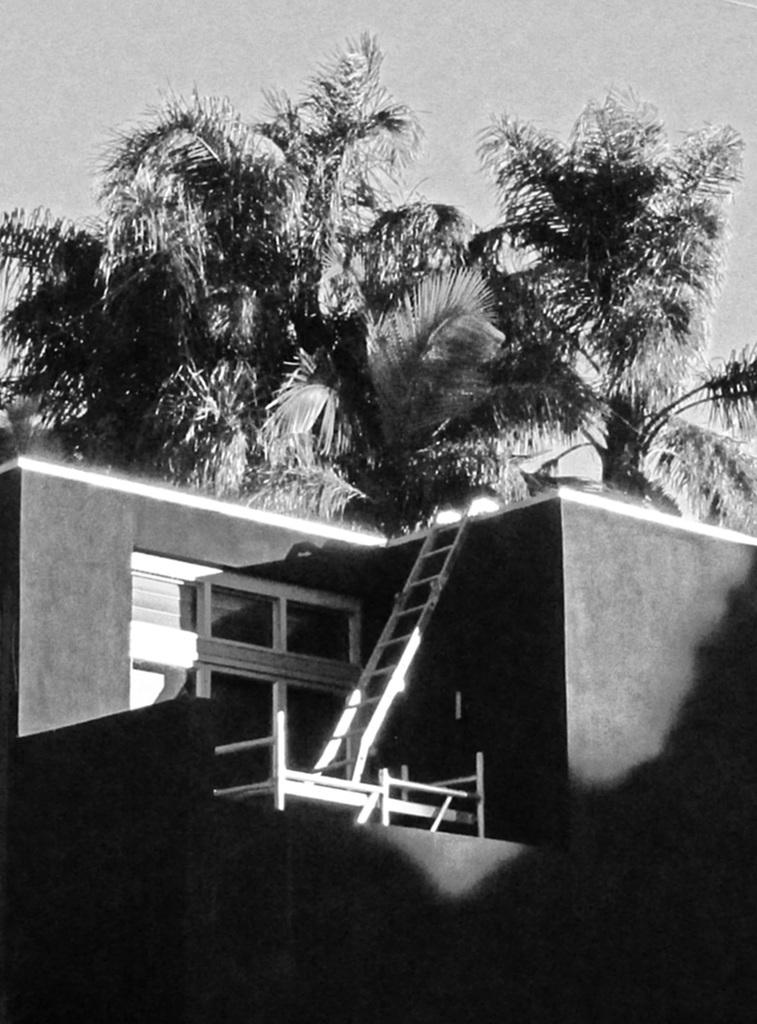What type of structure is present in the image? There is a building in the image. What object is present that might be used for reaching higher places? There is a ladder in the image. What type of natural vegetation is visible in the image? There are trees in the image. How many pies are being held by the giants in the image? There are no giants or pies present in the image. What year is depicted in the image? The image does not depict a specific year; it is a still image. 